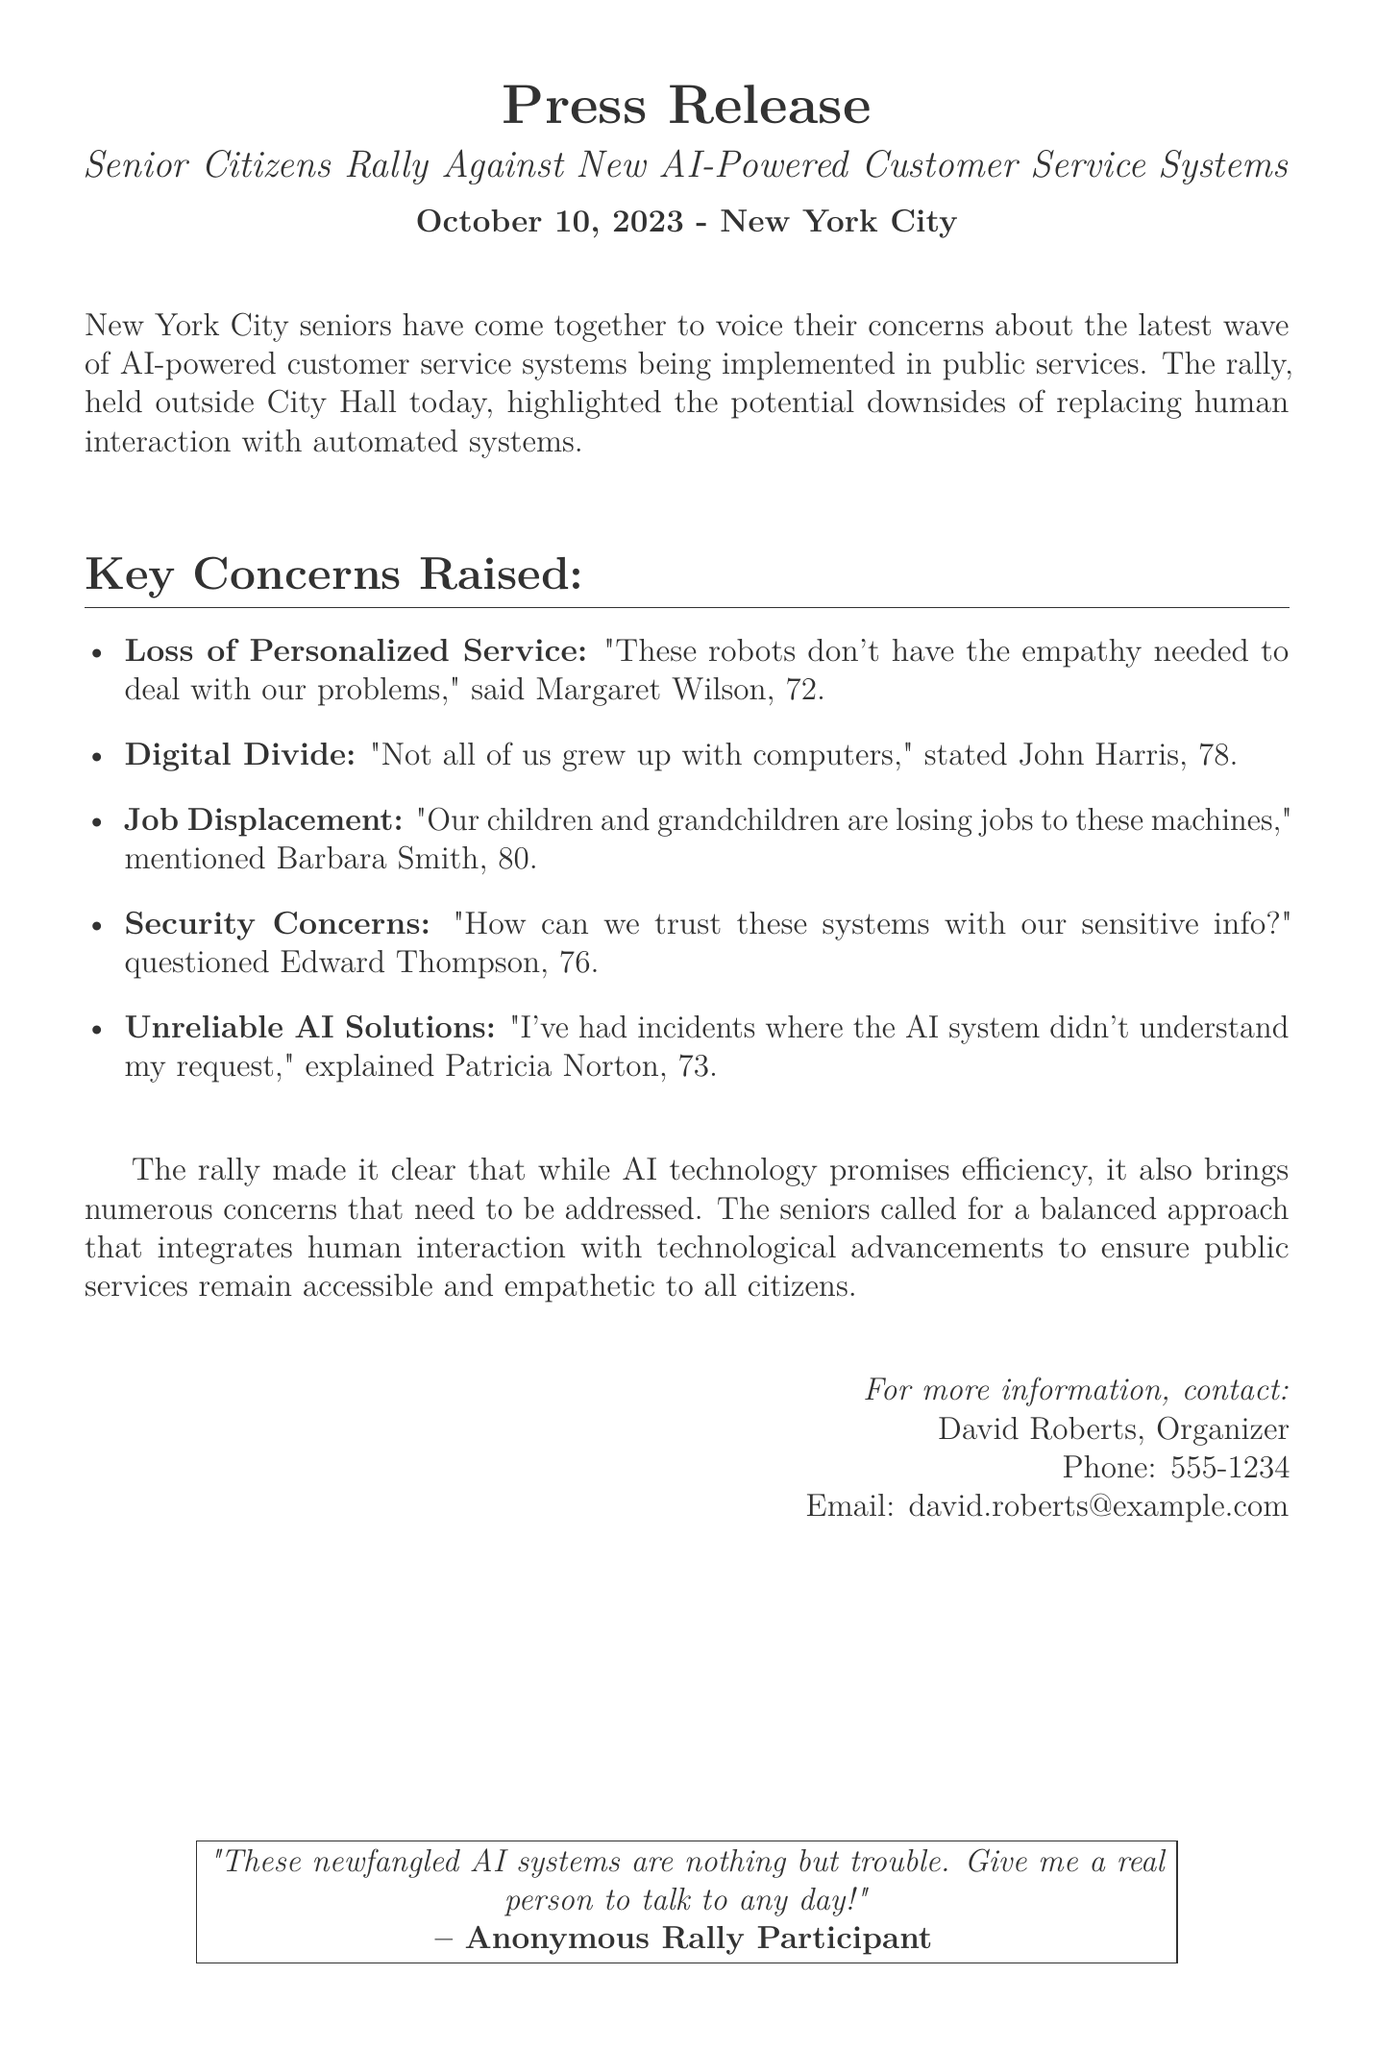What date was the rally held? The date of the rally can be found in the introduction of the document, stated as October 10, 2023.
Answer: October 10, 2023 Who is the organizer of the event? The organizer's information is presented at the end of the document, where David Roberts is mentioned as the contact person.
Answer: David Roberts What is one major concern regarding AI systems raised at the rally? The document lists several concerns raised by seniors, such as loss of personalized service, which reflects their main worry about AI.
Answer: Loss of Personalized Service What age is John Harris? The document explicitly states John Harris's age as 78 in his statement.
Answer: 78 What is a concern related to job displacement? The concern about job displacement is mentioned in Barbara Smith's quote regarding jobs lost to machines.
Answer: Job Displacement How did Patricia Norton describe her experience with AI systems? Patricia Norton explained her negative experience related to AI understanding her request, which highlights a reliability issue.
Answer: Unreliable AI Solutions What does the anonymous rally participant prefer over AI systems? The anonymous participant's statement in the box at the end of the document illustrates a preference for human interaction over dealing with AI.
Answer: A real person What is the setting of the rally? The document indicates that the rally took place outside City Hall in New York City, providing context for the location.
Answer: Outside City Hall 